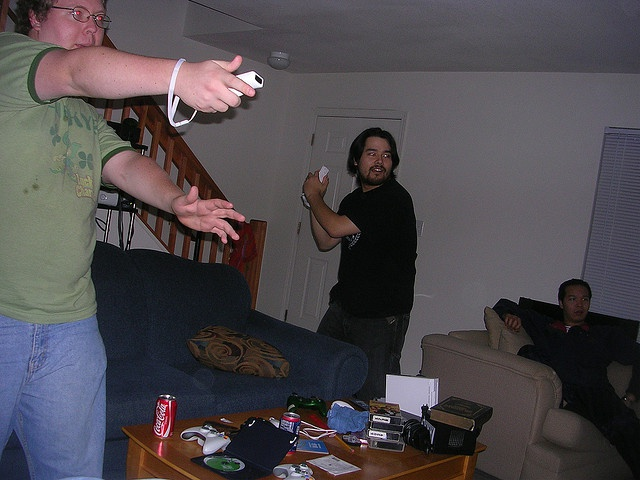Describe the objects in this image and their specific colors. I can see people in black and gray tones, couch in black and gray tones, people in black, maroon, and gray tones, couch in black tones, and people in black and gray tones in this image. 